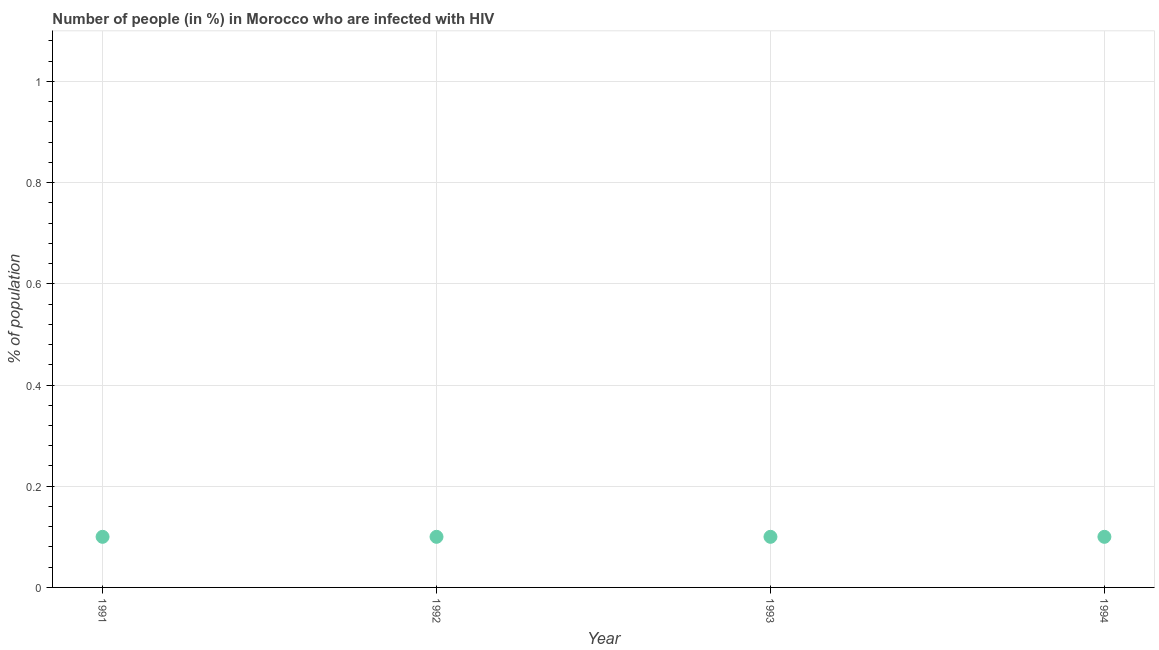What is the number of people infected with hiv in 1991?
Give a very brief answer. 0.1. In which year was the number of people infected with hiv minimum?
Offer a very short reply. 1991. What is the difference between the number of people infected with hiv in 1991 and 1992?
Your answer should be compact. 0. What is the median number of people infected with hiv?
Your answer should be compact. 0.1. In how many years, is the number of people infected with hiv greater than 0.28 %?
Offer a very short reply. 0. What is the difference between the highest and the second highest number of people infected with hiv?
Ensure brevity in your answer.  0. Does the number of people infected with hiv monotonically increase over the years?
Your answer should be compact. No. How many years are there in the graph?
Offer a very short reply. 4. What is the difference between two consecutive major ticks on the Y-axis?
Your answer should be very brief. 0.2. Does the graph contain grids?
Your answer should be very brief. Yes. What is the title of the graph?
Provide a succinct answer. Number of people (in %) in Morocco who are infected with HIV. What is the label or title of the X-axis?
Offer a very short reply. Year. What is the label or title of the Y-axis?
Offer a very short reply. % of population. What is the % of population in 1992?
Provide a succinct answer. 0.1. What is the % of population in 1993?
Ensure brevity in your answer.  0.1. What is the % of population in 1994?
Your response must be concise. 0.1. What is the difference between the % of population in 1991 and 1992?
Keep it short and to the point. 0. What is the difference between the % of population in 1991 and 1994?
Ensure brevity in your answer.  0. What is the difference between the % of population in 1992 and 1993?
Provide a succinct answer. 0. What is the difference between the % of population in 1992 and 1994?
Give a very brief answer. 0. What is the difference between the % of population in 1993 and 1994?
Keep it short and to the point. 0. What is the ratio of the % of population in 1991 to that in 1992?
Keep it short and to the point. 1. What is the ratio of the % of population in 1991 to that in 1993?
Your answer should be compact. 1. What is the ratio of the % of population in 1992 to that in 1994?
Your answer should be very brief. 1. What is the ratio of the % of population in 1993 to that in 1994?
Ensure brevity in your answer.  1. 